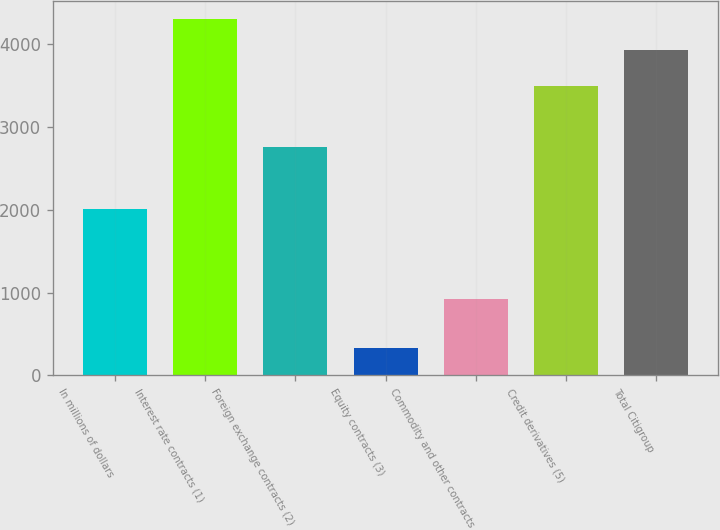Convert chart to OTSL. <chart><loc_0><loc_0><loc_500><loc_500><bar_chart><fcel>In millions of dollars<fcel>Interest rate contracts (1)<fcel>Foreign exchange contracts (2)<fcel>Equity contracts (3)<fcel>Commodity and other contracts<fcel>Credit derivatives (5)<fcel>Total Citigroup<nl><fcel>2009<fcel>4306.1<fcel>2762<fcel>334<fcel>924<fcel>3495<fcel>3932<nl></chart> 